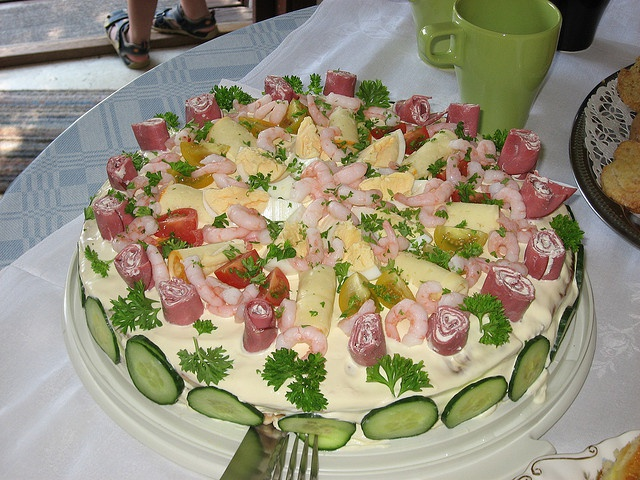Describe the objects in this image and their specific colors. I can see dining table in darkgray, darkgreen, beige, and tan tones, pizza in darkgreen, tan, and brown tones, cup in darkgreen and olive tones, bowl in darkgreen, black, gray, and olive tones, and people in darkgreen, black, maroon, gray, and darkgray tones in this image. 